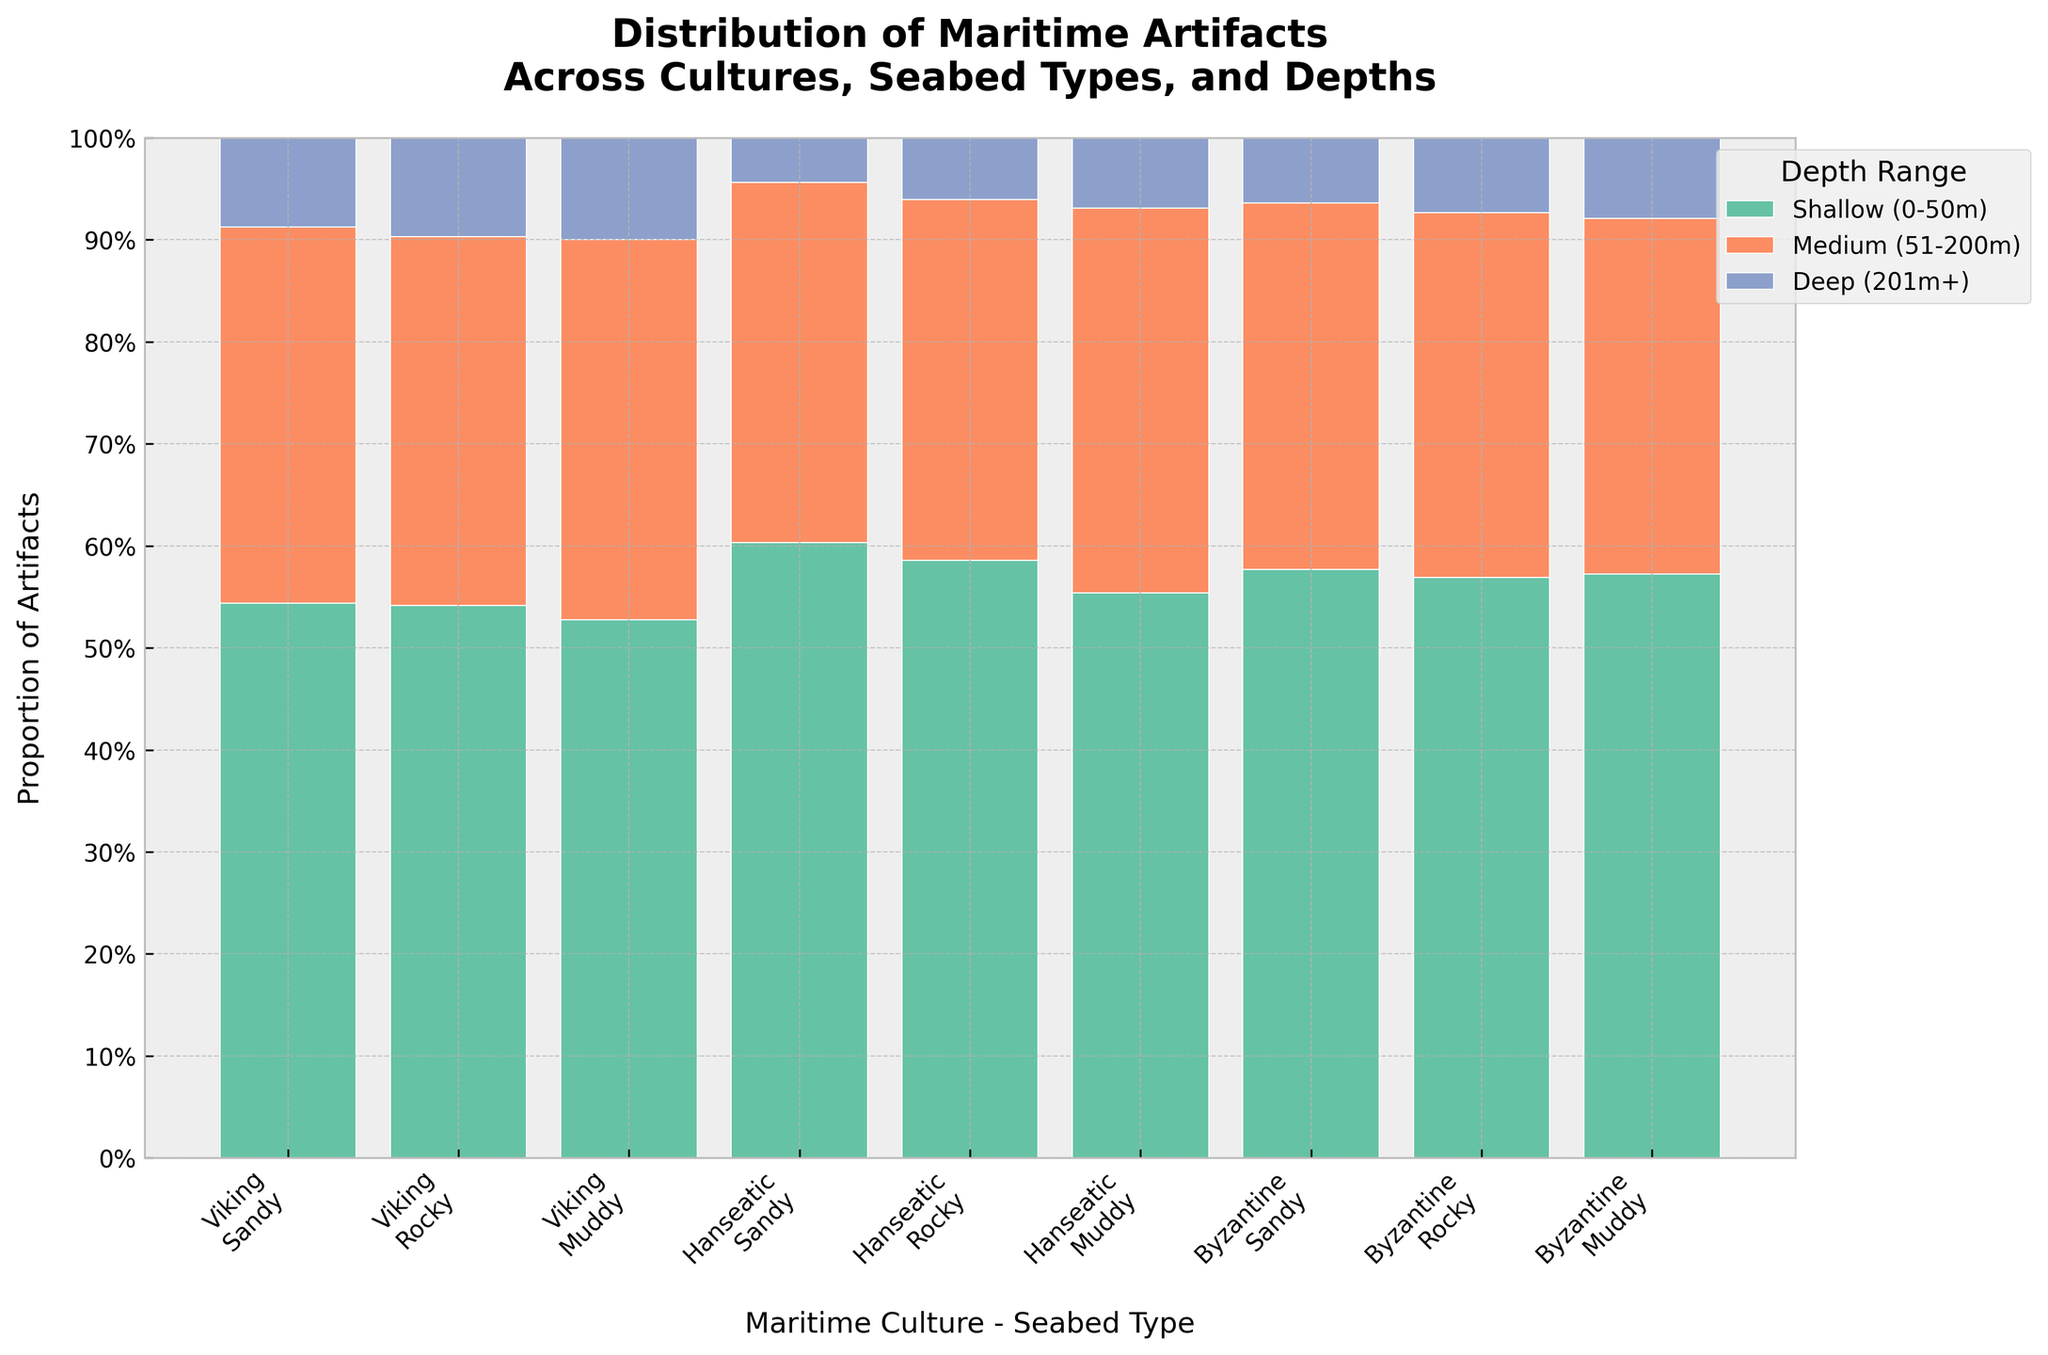What's the title of the chart? The title is located at the top of the chart and provides an overview of the chart's focus. In this case, it is "Distribution of Maritime Artifacts Across Cultures, Seabed Types, and Depths".
Answer: Distribution of Maritime Artifacts Across Cultures, Seabed Types, and Depths Which seabed type has the highest proportion of Viking artifacts in shallow waters? Look at the portion of the chart corresponding to Viking artifacts in shallow waters across each seabed type. The largest bar segment indicates the highest proportion.
Answer: Sandy How does the proportion of artifacts for the Byzantine culture compare across different depth ranges on a rocky seabed? Examine the stacked bars for the Byzantine culture across different depth ranges on a rocky seabed. Identify the proportions of each depth range by comparing the sizes of the color-coded segments.
Answer: Highest in Shallow, followed by Medium, then Deep Which culture shows the least variation in artifact distribution across the different seabed types? Compare the range of proportions for each culture across the three seabed types. The culture with the smallest range of proportions exhibits the least variation.
Answer: Hanseatic What depth range has the lowest overall representation in the chart for all cultures combined? Identify the color associated with each depth range and compare the overall sizes of these colors across all the stacked bars in the chart.
Answer: Deep (201m+) Which seabed type has the highest proportion of artifacts for the Viking culture in medium depth ranges? Locate the medium depth range bar segments for the Viking culture across different seabed types and compare their proportions.
Answer: Sandy What proportion of total artifacts for the Byzantine culture are found in medium depths on a sandy seabed? Find the segment for the Byzantine culture on a sandy seabed in medium depths and note its proportion in relation to the total Byzantine artifacts displayed in the chart.
Answer: 0.67 Compare the proportion of artifacts in shallow depths between the Viking and Hanseatic cultures on a rocky seabed. Which is higher? Look at the shallow-depth bar segments for both the Viking and Hanseatic cultures on a rocky seabed and compare their proportions.
Answer: Viking 